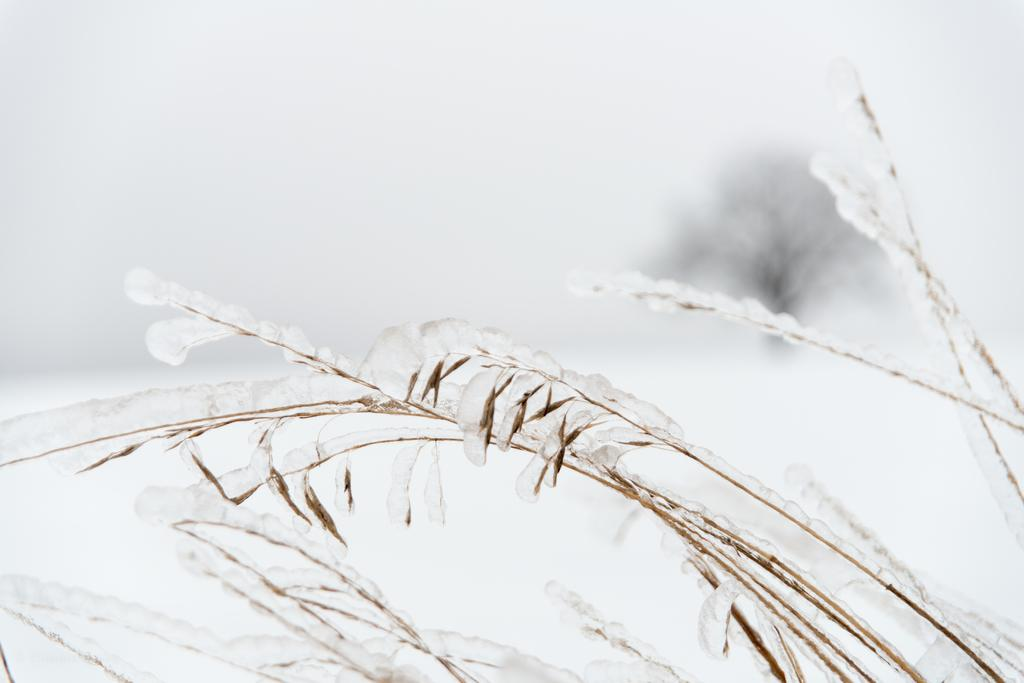What is present in the image? There is a plant in the image. How is the plant affected by the weather or environment? The plant is covered with snow. What can be seen in the background of the image? There is a tree visible in the background of the image. What color is the crayon used to draw the ghost in the image? There is no crayon or ghost present in the image; it features a plant covered with snow and a tree in the background. 